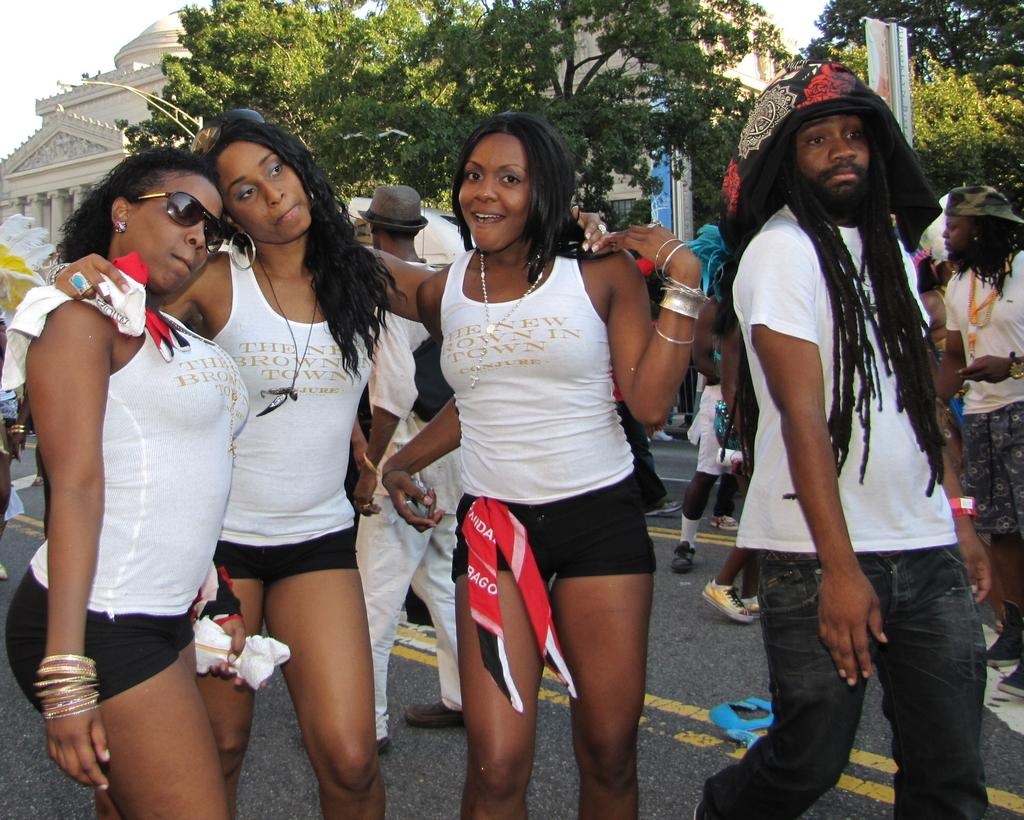What can be seen in the foreground of the image? There are persons standing in the front of the image. What are the expressions of the persons in the image? The persons are smiling. What is visible in the background of the image? There are buildings in the background of the image. What objects can be seen in the image besides the persons and buildings? There are poles in the image. What type of card is being used by the persons in the image? There is no card present in the image; the persons are simply standing and smiling. Can you tell me how many quinces are on the poles in the image? There are no quinces or any fruit present on the poles in the image. 